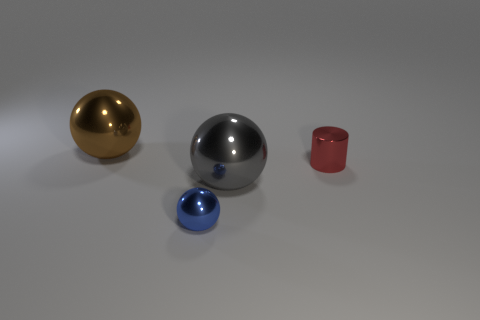The large object in front of the tiny cylinder has what shape?
Make the answer very short. Sphere. Is there anything else of the same color as the small metal cylinder?
Offer a terse response. No. Are there fewer metallic cylinders behind the tiny ball than big shiny balls?
Ensure brevity in your answer.  Yes. What number of brown shiny objects have the same size as the red shiny object?
Provide a short and direct response. 0. What is the shape of the tiny metallic object that is on the left side of the small thing that is behind the big thing that is in front of the big brown metal sphere?
Give a very brief answer. Sphere. What is the color of the large thing that is on the right side of the brown thing?
Provide a succinct answer. Gray. How many objects are big shiny objects that are left of the tiny blue shiny sphere or tiny things right of the blue shiny thing?
Your response must be concise. 2. What number of gray shiny things are the same shape as the tiny blue thing?
Provide a succinct answer. 1. There is a sphere that is the same size as the red metallic object; what color is it?
Ensure brevity in your answer.  Blue. There is a large sphere on the right side of the object in front of the large metal object that is in front of the big brown sphere; what color is it?
Offer a very short reply. Gray. 